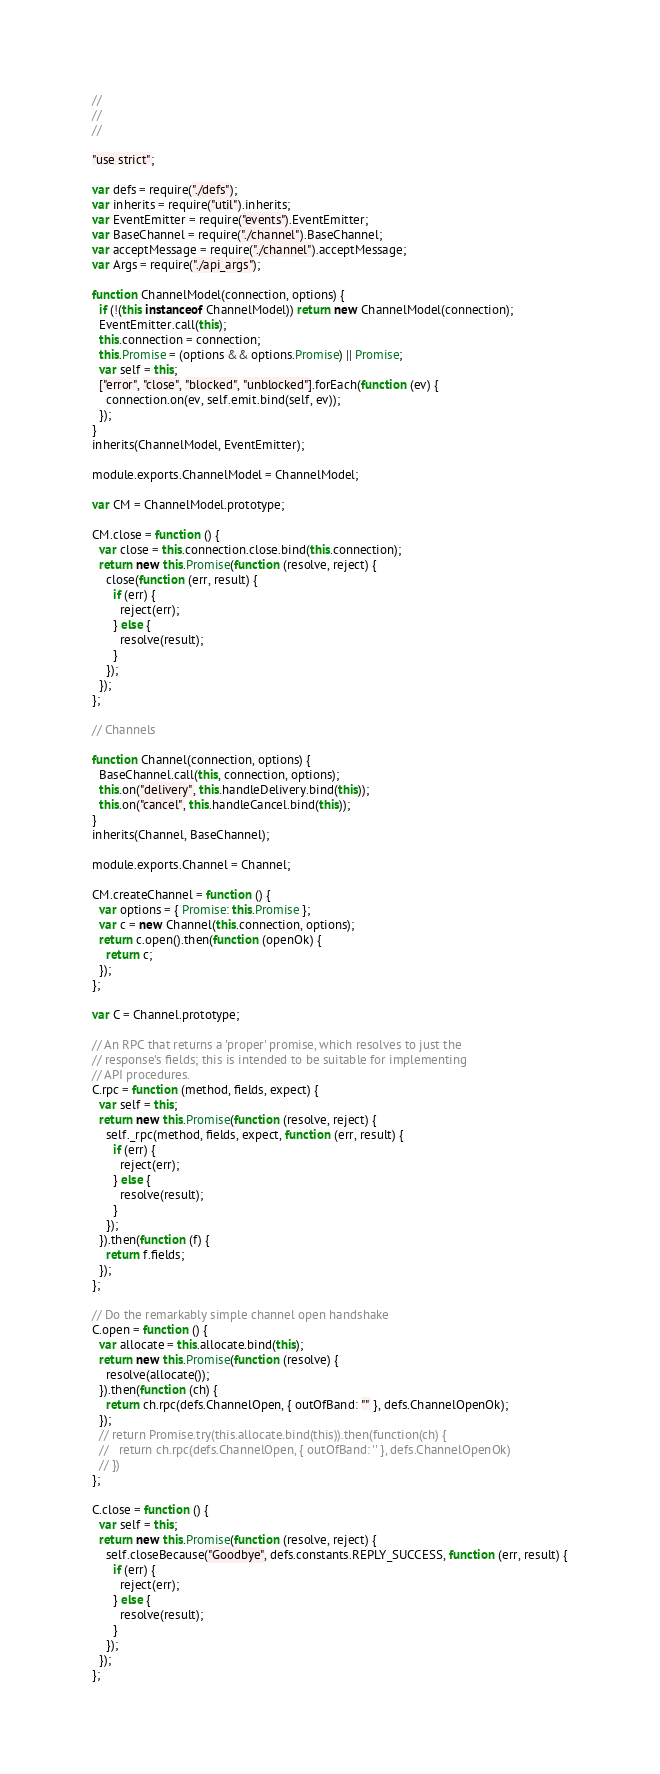Convert code to text. <code><loc_0><loc_0><loc_500><loc_500><_JavaScript_>//
//
//

"use strict";

var defs = require("./defs");
var inherits = require("util").inherits;
var EventEmitter = require("events").EventEmitter;
var BaseChannel = require("./channel").BaseChannel;
var acceptMessage = require("./channel").acceptMessage;
var Args = require("./api_args");

function ChannelModel(connection, options) {
  if (!(this instanceof ChannelModel)) return new ChannelModel(connection);
  EventEmitter.call(this);
  this.connection = connection;
  this.Promise = (options && options.Promise) || Promise;
  var self = this;
  ["error", "close", "blocked", "unblocked"].forEach(function (ev) {
    connection.on(ev, self.emit.bind(self, ev));
  });
}
inherits(ChannelModel, EventEmitter);

module.exports.ChannelModel = ChannelModel;

var CM = ChannelModel.prototype;

CM.close = function () {
  var close = this.connection.close.bind(this.connection);
  return new this.Promise(function (resolve, reject) {
    close(function (err, result) {
      if (err) {
        reject(err);
      } else {
        resolve(result);
      }
    });
  });
};

// Channels

function Channel(connection, options) {
  BaseChannel.call(this, connection, options);
  this.on("delivery", this.handleDelivery.bind(this));
  this.on("cancel", this.handleCancel.bind(this));
}
inherits(Channel, BaseChannel);

module.exports.Channel = Channel;

CM.createChannel = function () {
  var options = { Promise: this.Promise };
  var c = new Channel(this.connection, options);
  return c.open().then(function (openOk) {
    return c;
  });
};

var C = Channel.prototype;

// An RPC that returns a 'proper' promise, which resolves to just the
// response's fields; this is intended to be suitable for implementing
// API procedures.
C.rpc = function (method, fields, expect) {
  var self = this;
  return new this.Promise(function (resolve, reject) {
    self._rpc(method, fields, expect, function (err, result) {
      if (err) {
        reject(err);
      } else {
        resolve(result);
      }
    });
  }).then(function (f) {
    return f.fields;
  });
};

// Do the remarkably simple channel open handshake
C.open = function () {
  var allocate = this.allocate.bind(this);
  return new this.Promise(function (resolve) {
    resolve(allocate());
  }).then(function (ch) {
    return ch.rpc(defs.ChannelOpen, { outOfBand: "" }, defs.ChannelOpenOk);
  });
  // return Promise.try(this.allocate.bind(this)).then(function(ch) {
  //   return ch.rpc(defs.ChannelOpen, { outOfBand: '' }, defs.ChannelOpenOk)
  // })
};

C.close = function () {
  var self = this;
  return new this.Promise(function (resolve, reject) {
    self.closeBecause("Goodbye", defs.constants.REPLY_SUCCESS, function (err, result) {
      if (err) {
        reject(err);
      } else {
        resolve(result);
      }
    });
  });
};
</code> 